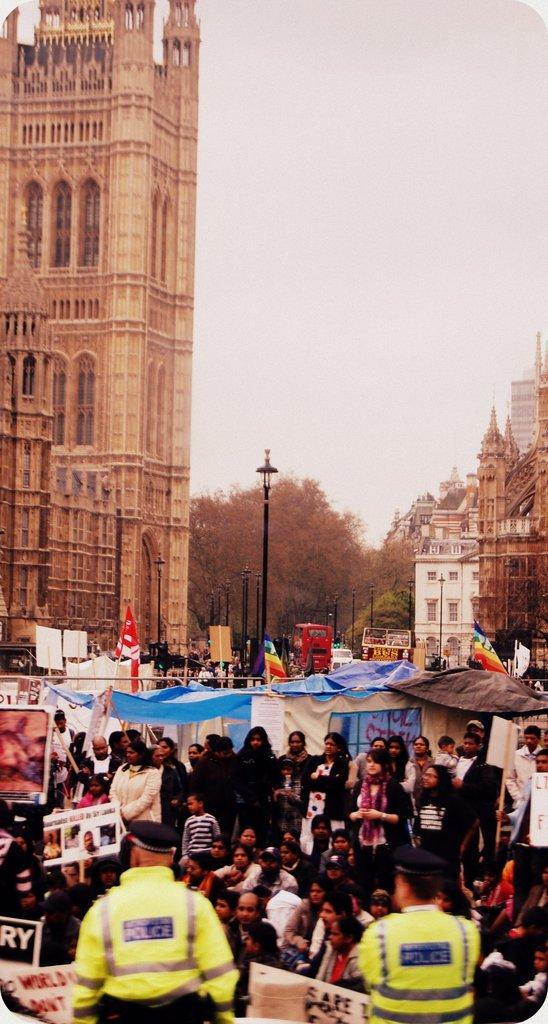What are the people in the image holding? The people in the image are holding posters. What can be seen in the foreground area of the image? There are cops in the foreground area of the image. What is visible in the background of the image? Vehicles, poles, trees, buildings, and the sky are visible in the background of the image. What type of flesh can be seen on the seashore in the image? There is no seashore or flesh present in the image; it features people holding posters and a background with vehicles, poles, trees, buildings, and the sky. 